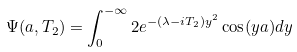Convert formula to latex. <formula><loc_0><loc_0><loc_500><loc_500>\Psi ( a , T _ { 2 } ) = \int _ { 0 } ^ { - \infty } 2 e ^ { - ( \lambda - i T _ { 2 } ) y ^ { 2 } } \cos ( y a ) d y</formula> 